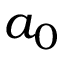<formula> <loc_0><loc_0><loc_500><loc_500>a _ { 0 }</formula> 